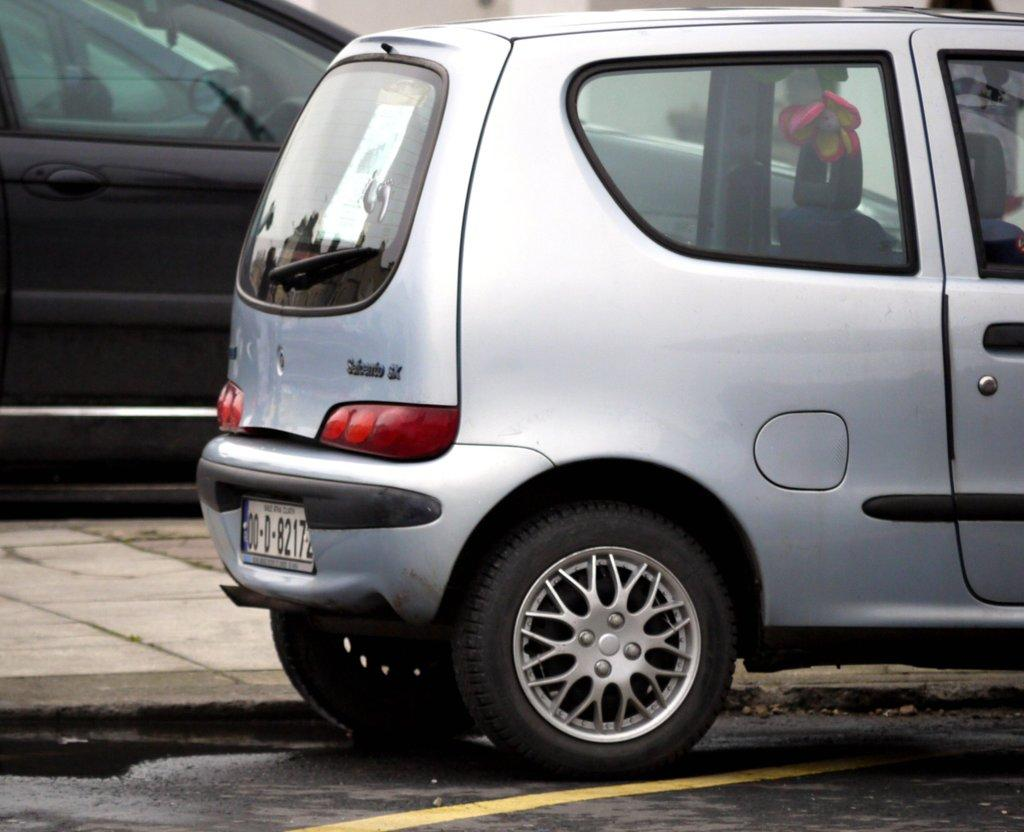What can be seen on the road in the image? There are cars on the road in the image. What is located next to the road in the image? There is a sidewalk in the image. Can you describe anything unusual inside one of the cars? Yes, there is a doll inside one of the cars. What type of reward can be seen hanging from the boats in the image? There are no boats present in the image, so there is no reward hanging from them. 